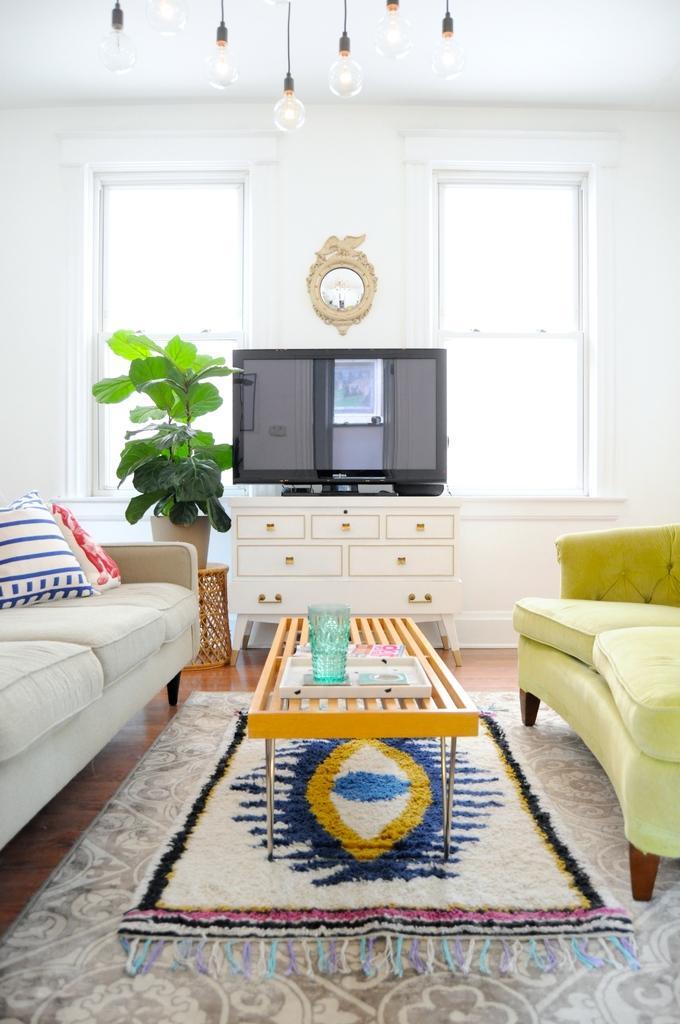In one or two sentences, can you explain what this image depicts? A room where we have two sofas and a table in between the sofas and on the table we have a glass and in front of the sofas there is a tv and above the tv we have a clock watch and also there are two windows and also a plant on the table. we also have six bulbs and a pillow on the sofa and the mat on the floor. 